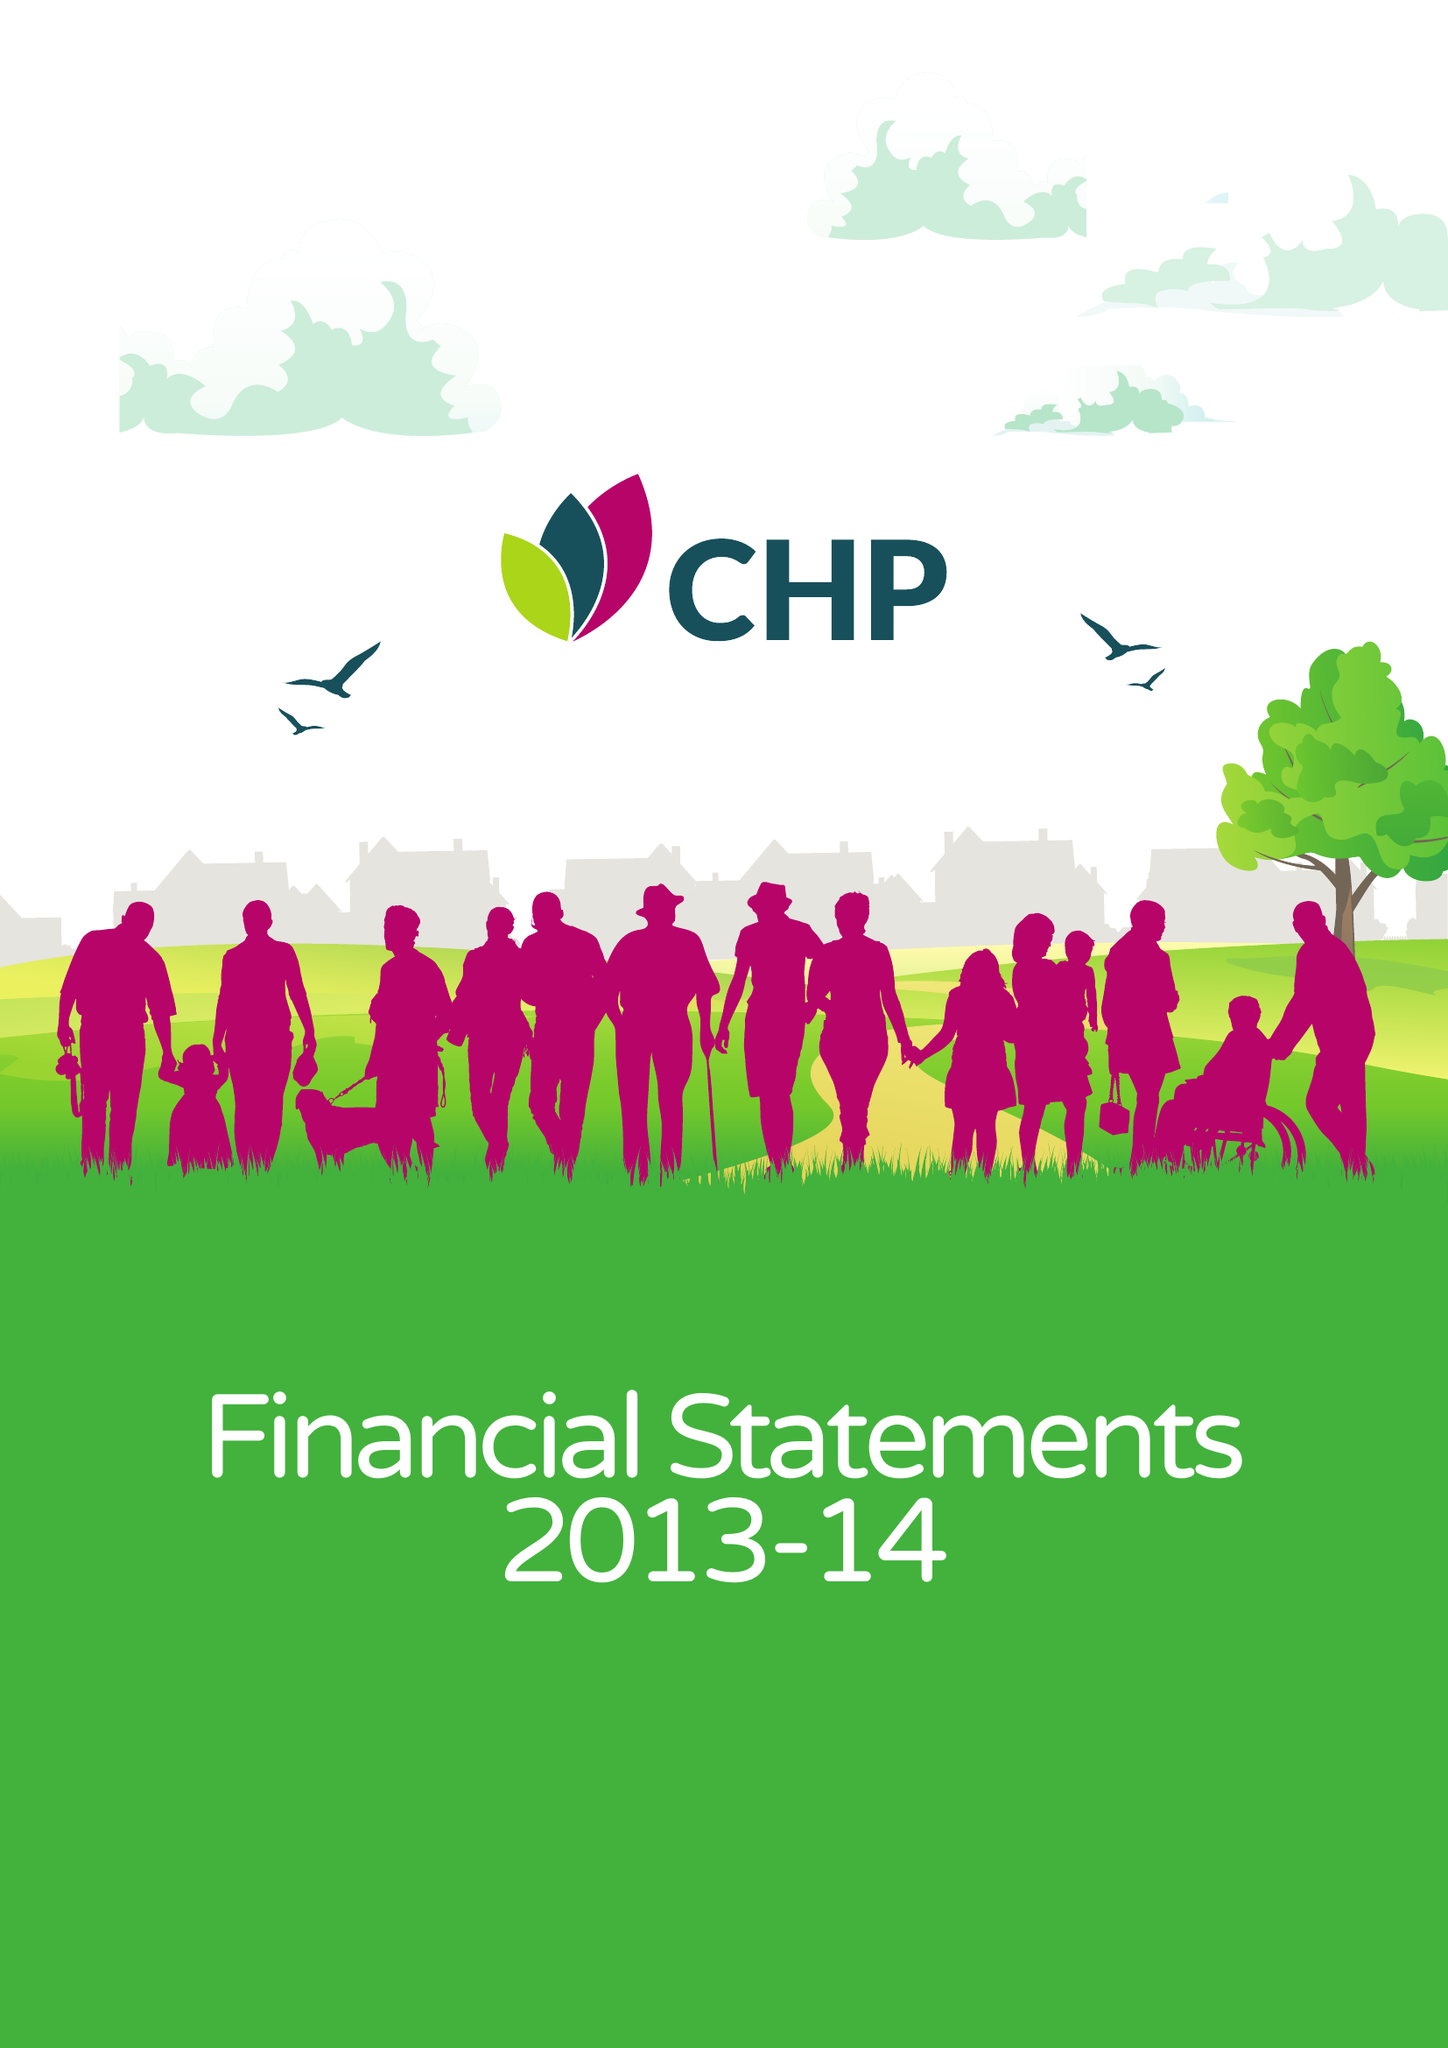What is the value for the income_annually_in_british_pounds?
Answer the question using a single word or phrase. 42876000.00 